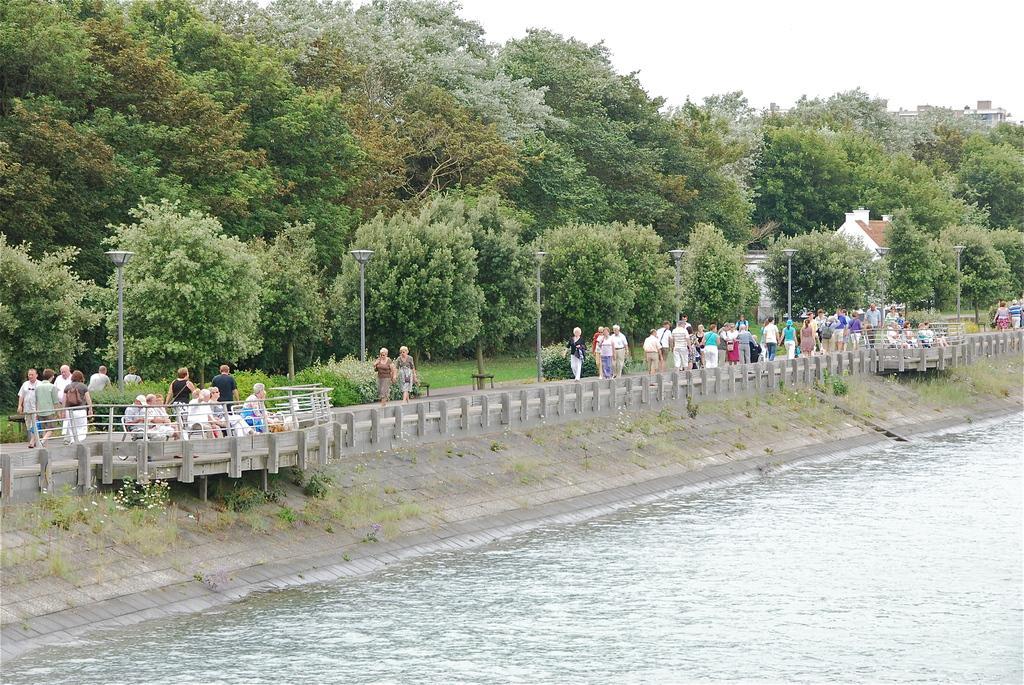In one or two sentences, can you explain what this image depicts? In this picture we can observe water. There is a cement railing. We can observe some people walking in this path. There are trees and poles. In the background there is a sky. 